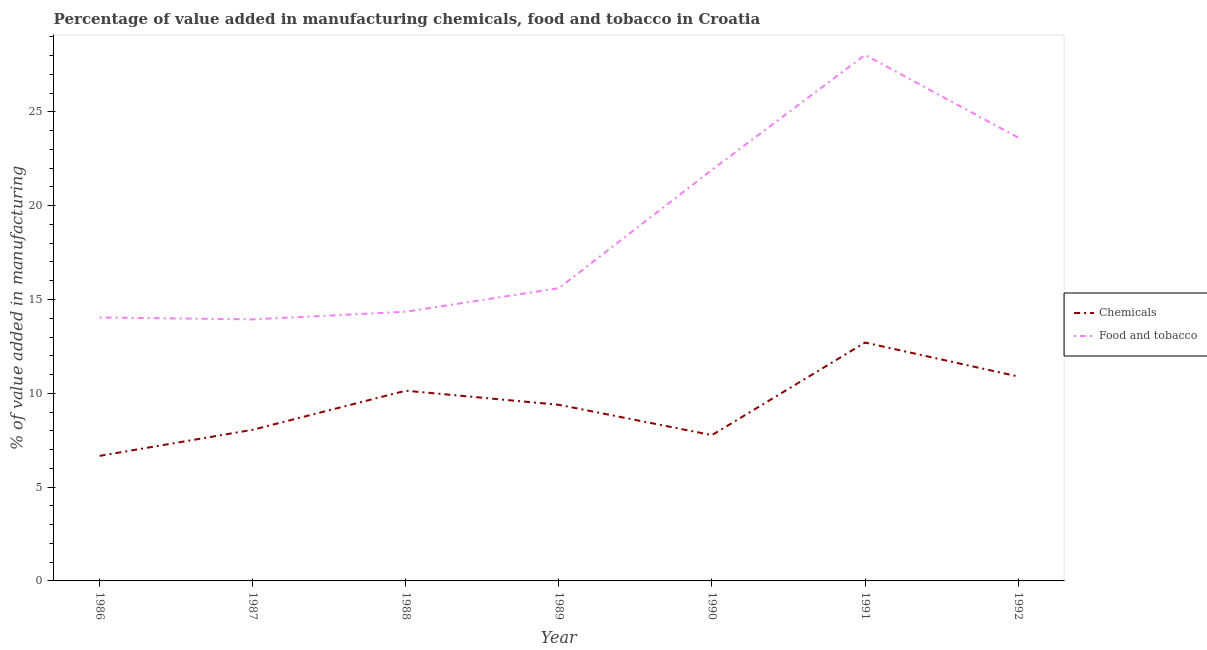Does the line corresponding to value added by  manufacturing chemicals intersect with the line corresponding to value added by manufacturing food and tobacco?
Offer a terse response. No. What is the value added by manufacturing food and tobacco in 1992?
Offer a terse response. 23.63. Across all years, what is the maximum value added by  manufacturing chemicals?
Give a very brief answer. 12.7. Across all years, what is the minimum value added by manufacturing food and tobacco?
Ensure brevity in your answer.  13.94. In which year was the value added by manufacturing food and tobacco maximum?
Your response must be concise. 1991. What is the total value added by manufacturing food and tobacco in the graph?
Your response must be concise. 131.51. What is the difference between the value added by  manufacturing chemicals in 1986 and that in 1992?
Keep it short and to the point. -4.23. What is the difference between the value added by  manufacturing chemicals in 1987 and the value added by manufacturing food and tobacco in 1991?
Provide a short and direct response. -19.98. What is the average value added by manufacturing food and tobacco per year?
Provide a succinct answer. 18.79. In the year 1987, what is the difference between the value added by manufacturing food and tobacco and value added by  manufacturing chemicals?
Provide a short and direct response. 5.88. What is the ratio of the value added by  manufacturing chemicals in 1990 to that in 1991?
Your answer should be very brief. 0.61. What is the difference between the highest and the second highest value added by  manufacturing chemicals?
Give a very brief answer. 1.81. What is the difference between the highest and the lowest value added by manufacturing food and tobacco?
Give a very brief answer. 14.1. Is the value added by manufacturing food and tobacco strictly less than the value added by  manufacturing chemicals over the years?
Your answer should be very brief. No. How many years are there in the graph?
Offer a terse response. 7. Are the values on the major ticks of Y-axis written in scientific E-notation?
Keep it short and to the point. No. Does the graph contain any zero values?
Make the answer very short. No. How many legend labels are there?
Offer a very short reply. 2. What is the title of the graph?
Your response must be concise. Percentage of value added in manufacturing chemicals, food and tobacco in Croatia. Does "Goods" appear as one of the legend labels in the graph?
Ensure brevity in your answer.  No. What is the label or title of the Y-axis?
Give a very brief answer. % of value added in manufacturing. What is the % of value added in manufacturing in Chemicals in 1986?
Ensure brevity in your answer.  6.67. What is the % of value added in manufacturing in Food and tobacco in 1986?
Provide a short and direct response. 14.04. What is the % of value added in manufacturing of Chemicals in 1987?
Your answer should be compact. 8.06. What is the % of value added in manufacturing in Food and tobacco in 1987?
Your response must be concise. 13.94. What is the % of value added in manufacturing in Chemicals in 1988?
Keep it short and to the point. 10.14. What is the % of value added in manufacturing in Food and tobacco in 1988?
Make the answer very short. 14.35. What is the % of value added in manufacturing of Chemicals in 1989?
Keep it short and to the point. 9.39. What is the % of value added in manufacturing of Food and tobacco in 1989?
Provide a succinct answer. 15.6. What is the % of value added in manufacturing in Chemicals in 1990?
Keep it short and to the point. 7.77. What is the % of value added in manufacturing of Food and tobacco in 1990?
Provide a succinct answer. 21.91. What is the % of value added in manufacturing in Chemicals in 1991?
Provide a succinct answer. 12.7. What is the % of value added in manufacturing in Food and tobacco in 1991?
Make the answer very short. 28.04. What is the % of value added in manufacturing of Chemicals in 1992?
Provide a short and direct response. 10.9. What is the % of value added in manufacturing of Food and tobacco in 1992?
Offer a very short reply. 23.63. Across all years, what is the maximum % of value added in manufacturing in Chemicals?
Give a very brief answer. 12.7. Across all years, what is the maximum % of value added in manufacturing of Food and tobacco?
Your answer should be very brief. 28.04. Across all years, what is the minimum % of value added in manufacturing in Chemicals?
Your answer should be compact. 6.67. Across all years, what is the minimum % of value added in manufacturing of Food and tobacco?
Offer a terse response. 13.94. What is the total % of value added in manufacturing in Chemicals in the graph?
Offer a terse response. 65.62. What is the total % of value added in manufacturing of Food and tobacco in the graph?
Make the answer very short. 131.51. What is the difference between the % of value added in manufacturing of Chemicals in 1986 and that in 1987?
Give a very brief answer. -1.39. What is the difference between the % of value added in manufacturing of Food and tobacco in 1986 and that in 1987?
Provide a short and direct response. 0.1. What is the difference between the % of value added in manufacturing in Chemicals in 1986 and that in 1988?
Your response must be concise. -3.47. What is the difference between the % of value added in manufacturing of Food and tobacco in 1986 and that in 1988?
Ensure brevity in your answer.  -0.31. What is the difference between the % of value added in manufacturing of Chemicals in 1986 and that in 1989?
Keep it short and to the point. -2.72. What is the difference between the % of value added in manufacturing of Food and tobacco in 1986 and that in 1989?
Provide a succinct answer. -1.56. What is the difference between the % of value added in manufacturing in Chemicals in 1986 and that in 1990?
Ensure brevity in your answer.  -1.11. What is the difference between the % of value added in manufacturing of Food and tobacco in 1986 and that in 1990?
Offer a very short reply. -7.87. What is the difference between the % of value added in manufacturing in Chemicals in 1986 and that in 1991?
Offer a very short reply. -6.04. What is the difference between the % of value added in manufacturing in Food and tobacco in 1986 and that in 1991?
Offer a terse response. -13.99. What is the difference between the % of value added in manufacturing in Chemicals in 1986 and that in 1992?
Offer a terse response. -4.23. What is the difference between the % of value added in manufacturing of Food and tobacco in 1986 and that in 1992?
Ensure brevity in your answer.  -9.59. What is the difference between the % of value added in manufacturing in Chemicals in 1987 and that in 1988?
Your answer should be very brief. -2.08. What is the difference between the % of value added in manufacturing in Food and tobacco in 1987 and that in 1988?
Give a very brief answer. -0.41. What is the difference between the % of value added in manufacturing of Chemicals in 1987 and that in 1989?
Make the answer very short. -1.33. What is the difference between the % of value added in manufacturing of Food and tobacco in 1987 and that in 1989?
Provide a succinct answer. -1.66. What is the difference between the % of value added in manufacturing in Chemicals in 1987 and that in 1990?
Provide a succinct answer. 0.29. What is the difference between the % of value added in manufacturing of Food and tobacco in 1987 and that in 1990?
Give a very brief answer. -7.97. What is the difference between the % of value added in manufacturing of Chemicals in 1987 and that in 1991?
Your answer should be compact. -4.65. What is the difference between the % of value added in manufacturing in Food and tobacco in 1987 and that in 1991?
Offer a very short reply. -14.1. What is the difference between the % of value added in manufacturing in Chemicals in 1987 and that in 1992?
Make the answer very short. -2.84. What is the difference between the % of value added in manufacturing in Food and tobacco in 1987 and that in 1992?
Make the answer very short. -9.69. What is the difference between the % of value added in manufacturing of Chemicals in 1988 and that in 1989?
Offer a terse response. 0.75. What is the difference between the % of value added in manufacturing of Food and tobacco in 1988 and that in 1989?
Offer a very short reply. -1.26. What is the difference between the % of value added in manufacturing in Chemicals in 1988 and that in 1990?
Keep it short and to the point. 2.37. What is the difference between the % of value added in manufacturing of Food and tobacco in 1988 and that in 1990?
Your answer should be compact. -7.57. What is the difference between the % of value added in manufacturing in Chemicals in 1988 and that in 1991?
Your answer should be compact. -2.57. What is the difference between the % of value added in manufacturing in Food and tobacco in 1988 and that in 1991?
Offer a terse response. -13.69. What is the difference between the % of value added in manufacturing in Chemicals in 1988 and that in 1992?
Offer a terse response. -0.76. What is the difference between the % of value added in manufacturing of Food and tobacco in 1988 and that in 1992?
Give a very brief answer. -9.28. What is the difference between the % of value added in manufacturing of Chemicals in 1989 and that in 1990?
Offer a terse response. 1.62. What is the difference between the % of value added in manufacturing of Food and tobacco in 1989 and that in 1990?
Keep it short and to the point. -6.31. What is the difference between the % of value added in manufacturing of Chemicals in 1989 and that in 1991?
Give a very brief answer. -3.32. What is the difference between the % of value added in manufacturing in Food and tobacco in 1989 and that in 1991?
Offer a very short reply. -12.43. What is the difference between the % of value added in manufacturing in Chemicals in 1989 and that in 1992?
Provide a succinct answer. -1.51. What is the difference between the % of value added in manufacturing of Food and tobacco in 1989 and that in 1992?
Your response must be concise. -8.03. What is the difference between the % of value added in manufacturing of Chemicals in 1990 and that in 1991?
Your response must be concise. -4.93. What is the difference between the % of value added in manufacturing of Food and tobacco in 1990 and that in 1991?
Give a very brief answer. -6.12. What is the difference between the % of value added in manufacturing of Chemicals in 1990 and that in 1992?
Ensure brevity in your answer.  -3.12. What is the difference between the % of value added in manufacturing of Food and tobacco in 1990 and that in 1992?
Your answer should be very brief. -1.72. What is the difference between the % of value added in manufacturing in Chemicals in 1991 and that in 1992?
Offer a very short reply. 1.81. What is the difference between the % of value added in manufacturing of Food and tobacco in 1991 and that in 1992?
Offer a terse response. 4.41. What is the difference between the % of value added in manufacturing of Chemicals in 1986 and the % of value added in manufacturing of Food and tobacco in 1987?
Give a very brief answer. -7.28. What is the difference between the % of value added in manufacturing in Chemicals in 1986 and the % of value added in manufacturing in Food and tobacco in 1988?
Keep it short and to the point. -7.68. What is the difference between the % of value added in manufacturing of Chemicals in 1986 and the % of value added in manufacturing of Food and tobacco in 1989?
Give a very brief answer. -8.94. What is the difference between the % of value added in manufacturing in Chemicals in 1986 and the % of value added in manufacturing in Food and tobacco in 1990?
Provide a succinct answer. -15.25. What is the difference between the % of value added in manufacturing of Chemicals in 1986 and the % of value added in manufacturing of Food and tobacco in 1991?
Your response must be concise. -21.37. What is the difference between the % of value added in manufacturing in Chemicals in 1986 and the % of value added in manufacturing in Food and tobacco in 1992?
Your answer should be compact. -16.96. What is the difference between the % of value added in manufacturing in Chemicals in 1987 and the % of value added in manufacturing in Food and tobacco in 1988?
Offer a terse response. -6.29. What is the difference between the % of value added in manufacturing in Chemicals in 1987 and the % of value added in manufacturing in Food and tobacco in 1989?
Provide a short and direct response. -7.55. What is the difference between the % of value added in manufacturing of Chemicals in 1987 and the % of value added in manufacturing of Food and tobacco in 1990?
Offer a very short reply. -13.86. What is the difference between the % of value added in manufacturing in Chemicals in 1987 and the % of value added in manufacturing in Food and tobacco in 1991?
Provide a short and direct response. -19.98. What is the difference between the % of value added in manufacturing in Chemicals in 1987 and the % of value added in manufacturing in Food and tobacco in 1992?
Make the answer very short. -15.57. What is the difference between the % of value added in manufacturing in Chemicals in 1988 and the % of value added in manufacturing in Food and tobacco in 1989?
Your answer should be compact. -5.47. What is the difference between the % of value added in manufacturing in Chemicals in 1988 and the % of value added in manufacturing in Food and tobacco in 1990?
Offer a terse response. -11.77. What is the difference between the % of value added in manufacturing in Chemicals in 1988 and the % of value added in manufacturing in Food and tobacco in 1991?
Make the answer very short. -17.9. What is the difference between the % of value added in manufacturing of Chemicals in 1988 and the % of value added in manufacturing of Food and tobacco in 1992?
Your answer should be very brief. -13.49. What is the difference between the % of value added in manufacturing of Chemicals in 1989 and the % of value added in manufacturing of Food and tobacco in 1990?
Give a very brief answer. -12.53. What is the difference between the % of value added in manufacturing of Chemicals in 1989 and the % of value added in manufacturing of Food and tobacco in 1991?
Your response must be concise. -18.65. What is the difference between the % of value added in manufacturing in Chemicals in 1989 and the % of value added in manufacturing in Food and tobacco in 1992?
Offer a terse response. -14.24. What is the difference between the % of value added in manufacturing of Chemicals in 1990 and the % of value added in manufacturing of Food and tobacco in 1991?
Provide a succinct answer. -20.26. What is the difference between the % of value added in manufacturing in Chemicals in 1990 and the % of value added in manufacturing in Food and tobacco in 1992?
Provide a short and direct response. -15.86. What is the difference between the % of value added in manufacturing of Chemicals in 1991 and the % of value added in manufacturing of Food and tobacco in 1992?
Your answer should be compact. -10.92. What is the average % of value added in manufacturing of Chemicals per year?
Provide a short and direct response. 9.37. What is the average % of value added in manufacturing of Food and tobacco per year?
Make the answer very short. 18.79. In the year 1986, what is the difference between the % of value added in manufacturing in Chemicals and % of value added in manufacturing in Food and tobacco?
Ensure brevity in your answer.  -7.38. In the year 1987, what is the difference between the % of value added in manufacturing of Chemicals and % of value added in manufacturing of Food and tobacco?
Your response must be concise. -5.88. In the year 1988, what is the difference between the % of value added in manufacturing of Chemicals and % of value added in manufacturing of Food and tobacco?
Offer a terse response. -4.21. In the year 1989, what is the difference between the % of value added in manufacturing in Chemicals and % of value added in manufacturing in Food and tobacco?
Keep it short and to the point. -6.22. In the year 1990, what is the difference between the % of value added in manufacturing in Chemicals and % of value added in manufacturing in Food and tobacco?
Offer a terse response. -14.14. In the year 1991, what is the difference between the % of value added in manufacturing in Chemicals and % of value added in manufacturing in Food and tobacco?
Provide a short and direct response. -15.33. In the year 1992, what is the difference between the % of value added in manufacturing in Chemicals and % of value added in manufacturing in Food and tobacco?
Offer a very short reply. -12.73. What is the ratio of the % of value added in manufacturing of Chemicals in 1986 to that in 1987?
Make the answer very short. 0.83. What is the ratio of the % of value added in manufacturing in Food and tobacco in 1986 to that in 1987?
Offer a terse response. 1.01. What is the ratio of the % of value added in manufacturing of Chemicals in 1986 to that in 1988?
Offer a very short reply. 0.66. What is the ratio of the % of value added in manufacturing of Food and tobacco in 1986 to that in 1988?
Give a very brief answer. 0.98. What is the ratio of the % of value added in manufacturing of Chemicals in 1986 to that in 1989?
Your answer should be very brief. 0.71. What is the ratio of the % of value added in manufacturing of Food and tobacco in 1986 to that in 1989?
Give a very brief answer. 0.9. What is the ratio of the % of value added in manufacturing in Chemicals in 1986 to that in 1990?
Your answer should be very brief. 0.86. What is the ratio of the % of value added in manufacturing in Food and tobacco in 1986 to that in 1990?
Provide a short and direct response. 0.64. What is the ratio of the % of value added in manufacturing in Chemicals in 1986 to that in 1991?
Your answer should be very brief. 0.52. What is the ratio of the % of value added in manufacturing of Food and tobacco in 1986 to that in 1991?
Your response must be concise. 0.5. What is the ratio of the % of value added in manufacturing in Chemicals in 1986 to that in 1992?
Give a very brief answer. 0.61. What is the ratio of the % of value added in manufacturing in Food and tobacco in 1986 to that in 1992?
Provide a short and direct response. 0.59. What is the ratio of the % of value added in manufacturing of Chemicals in 1987 to that in 1988?
Offer a very short reply. 0.79. What is the ratio of the % of value added in manufacturing of Food and tobacco in 1987 to that in 1988?
Keep it short and to the point. 0.97. What is the ratio of the % of value added in manufacturing of Chemicals in 1987 to that in 1989?
Your response must be concise. 0.86. What is the ratio of the % of value added in manufacturing in Food and tobacco in 1987 to that in 1989?
Provide a succinct answer. 0.89. What is the ratio of the % of value added in manufacturing in Chemicals in 1987 to that in 1990?
Your answer should be compact. 1.04. What is the ratio of the % of value added in manufacturing in Food and tobacco in 1987 to that in 1990?
Offer a very short reply. 0.64. What is the ratio of the % of value added in manufacturing of Chemicals in 1987 to that in 1991?
Provide a succinct answer. 0.63. What is the ratio of the % of value added in manufacturing in Food and tobacco in 1987 to that in 1991?
Keep it short and to the point. 0.5. What is the ratio of the % of value added in manufacturing of Chemicals in 1987 to that in 1992?
Keep it short and to the point. 0.74. What is the ratio of the % of value added in manufacturing of Food and tobacco in 1987 to that in 1992?
Your response must be concise. 0.59. What is the ratio of the % of value added in manufacturing in Chemicals in 1988 to that in 1989?
Provide a succinct answer. 1.08. What is the ratio of the % of value added in manufacturing of Food and tobacco in 1988 to that in 1989?
Keep it short and to the point. 0.92. What is the ratio of the % of value added in manufacturing of Chemicals in 1988 to that in 1990?
Make the answer very short. 1.3. What is the ratio of the % of value added in manufacturing in Food and tobacco in 1988 to that in 1990?
Provide a succinct answer. 0.65. What is the ratio of the % of value added in manufacturing of Chemicals in 1988 to that in 1991?
Keep it short and to the point. 0.8. What is the ratio of the % of value added in manufacturing of Food and tobacco in 1988 to that in 1991?
Your answer should be very brief. 0.51. What is the ratio of the % of value added in manufacturing in Chemicals in 1988 to that in 1992?
Keep it short and to the point. 0.93. What is the ratio of the % of value added in manufacturing of Food and tobacco in 1988 to that in 1992?
Provide a succinct answer. 0.61. What is the ratio of the % of value added in manufacturing of Chemicals in 1989 to that in 1990?
Your answer should be compact. 1.21. What is the ratio of the % of value added in manufacturing of Food and tobacco in 1989 to that in 1990?
Ensure brevity in your answer.  0.71. What is the ratio of the % of value added in manufacturing of Chemicals in 1989 to that in 1991?
Keep it short and to the point. 0.74. What is the ratio of the % of value added in manufacturing in Food and tobacco in 1989 to that in 1991?
Your answer should be very brief. 0.56. What is the ratio of the % of value added in manufacturing of Chemicals in 1989 to that in 1992?
Your answer should be very brief. 0.86. What is the ratio of the % of value added in manufacturing of Food and tobacco in 1989 to that in 1992?
Your answer should be compact. 0.66. What is the ratio of the % of value added in manufacturing in Chemicals in 1990 to that in 1991?
Give a very brief answer. 0.61. What is the ratio of the % of value added in manufacturing of Food and tobacco in 1990 to that in 1991?
Your answer should be very brief. 0.78. What is the ratio of the % of value added in manufacturing of Chemicals in 1990 to that in 1992?
Keep it short and to the point. 0.71. What is the ratio of the % of value added in manufacturing of Food and tobacco in 1990 to that in 1992?
Offer a very short reply. 0.93. What is the ratio of the % of value added in manufacturing of Chemicals in 1991 to that in 1992?
Provide a short and direct response. 1.17. What is the ratio of the % of value added in manufacturing in Food and tobacco in 1991 to that in 1992?
Offer a terse response. 1.19. What is the difference between the highest and the second highest % of value added in manufacturing in Chemicals?
Your answer should be compact. 1.81. What is the difference between the highest and the second highest % of value added in manufacturing in Food and tobacco?
Offer a very short reply. 4.41. What is the difference between the highest and the lowest % of value added in manufacturing in Chemicals?
Ensure brevity in your answer.  6.04. What is the difference between the highest and the lowest % of value added in manufacturing of Food and tobacco?
Provide a succinct answer. 14.1. 